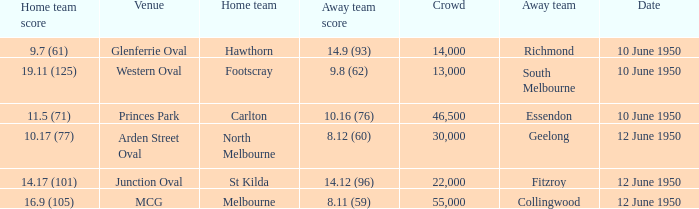Could you help me parse every detail presented in this table? {'header': ['Home team score', 'Venue', 'Home team', 'Away team score', 'Crowd', 'Away team', 'Date'], 'rows': [['9.7 (61)', 'Glenferrie Oval', 'Hawthorn', '14.9 (93)', '14,000', 'Richmond', '10 June 1950'], ['19.11 (125)', 'Western Oval', 'Footscray', '9.8 (62)', '13,000', 'South Melbourne', '10 June 1950'], ['11.5 (71)', 'Princes Park', 'Carlton', '10.16 (76)', '46,500', 'Essendon', '10 June 1950'], ['10.17 (77)', 'Arden Street Oval', 'North Melbourne', '8.12 (60)', '30,000', 'Geelong', '12 June 1950'], ['14.17 (101)', 'Junction Oval', 'St Kilda', '14.12 (96)', '22,000', 'Fitzroy', '12 June 1950'], ['16.9 (105)', 'MCG', 'Melbourne', '8.11 (59)', '55,000', 'Collingwood', '12 June 1950']]} What was the crowd when the VFL played MCG? 55000.0. 